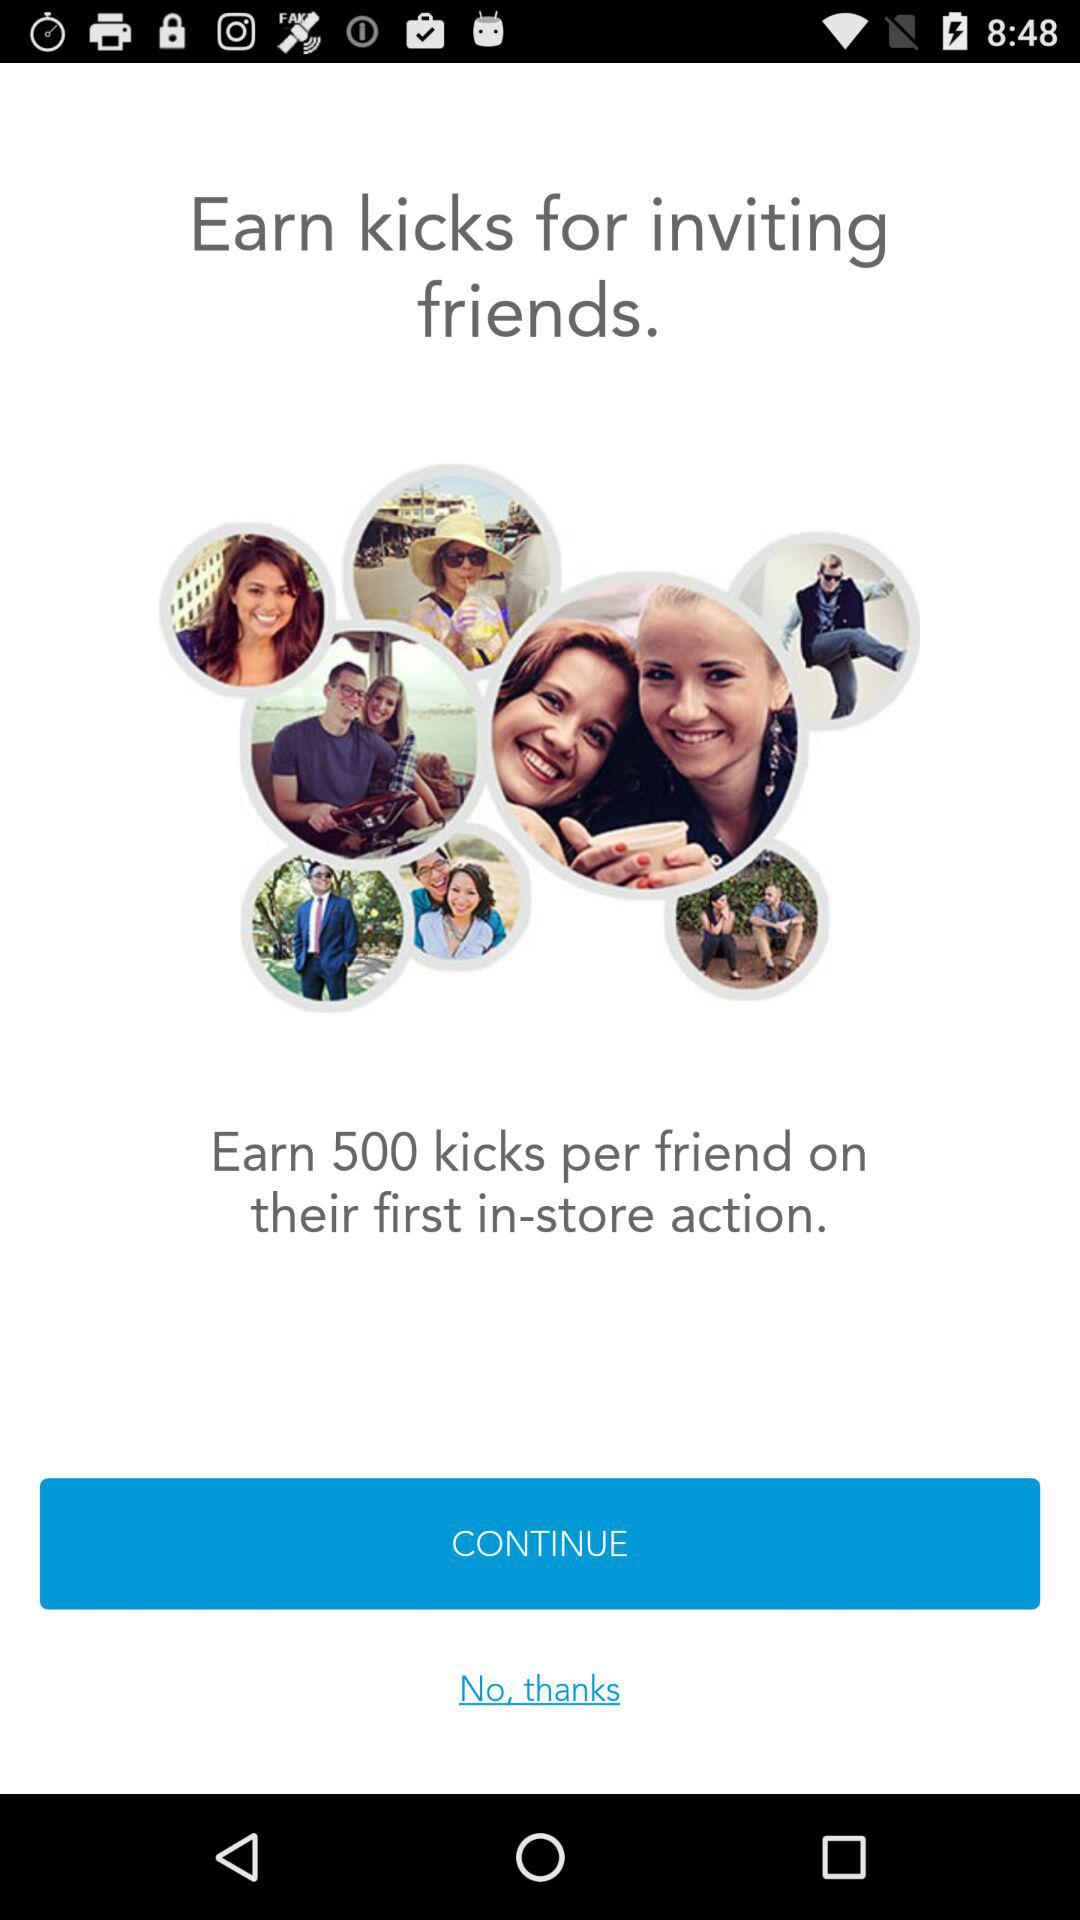How many kicks do you earn for inviting five friends?
Answer the question using a single word or phrase. 2500 